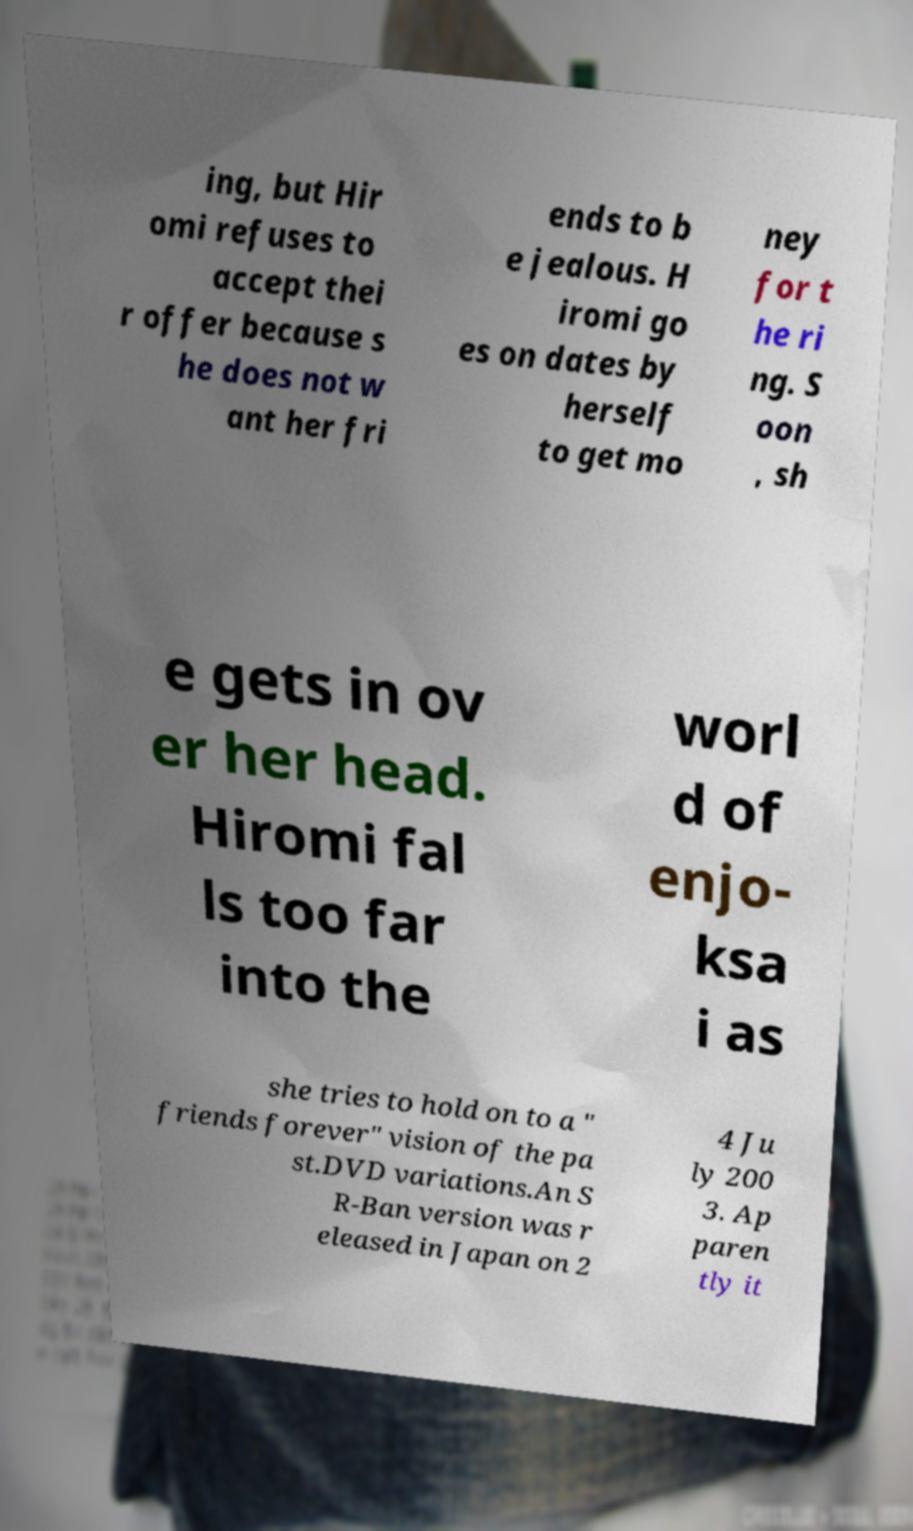I need the written content from this picture converted into text. Can you do that? ing, but Hir omi refuses to accept thei r offer because s he does not w ant her fri ends to b e jealous. H iromi go es on dates by herself to get mo ney for t he ri ng. S oon , sh e gets in ov er her head. Hiromi fal ls too far into the worl d of enjo- ksa i as she tries to hold on to a " friends forever" vision of the pa st.DVD variations.An S R-Ban version was r eleased in Japan on 2 4 Ju ly 200 3. Ap paren tly it 